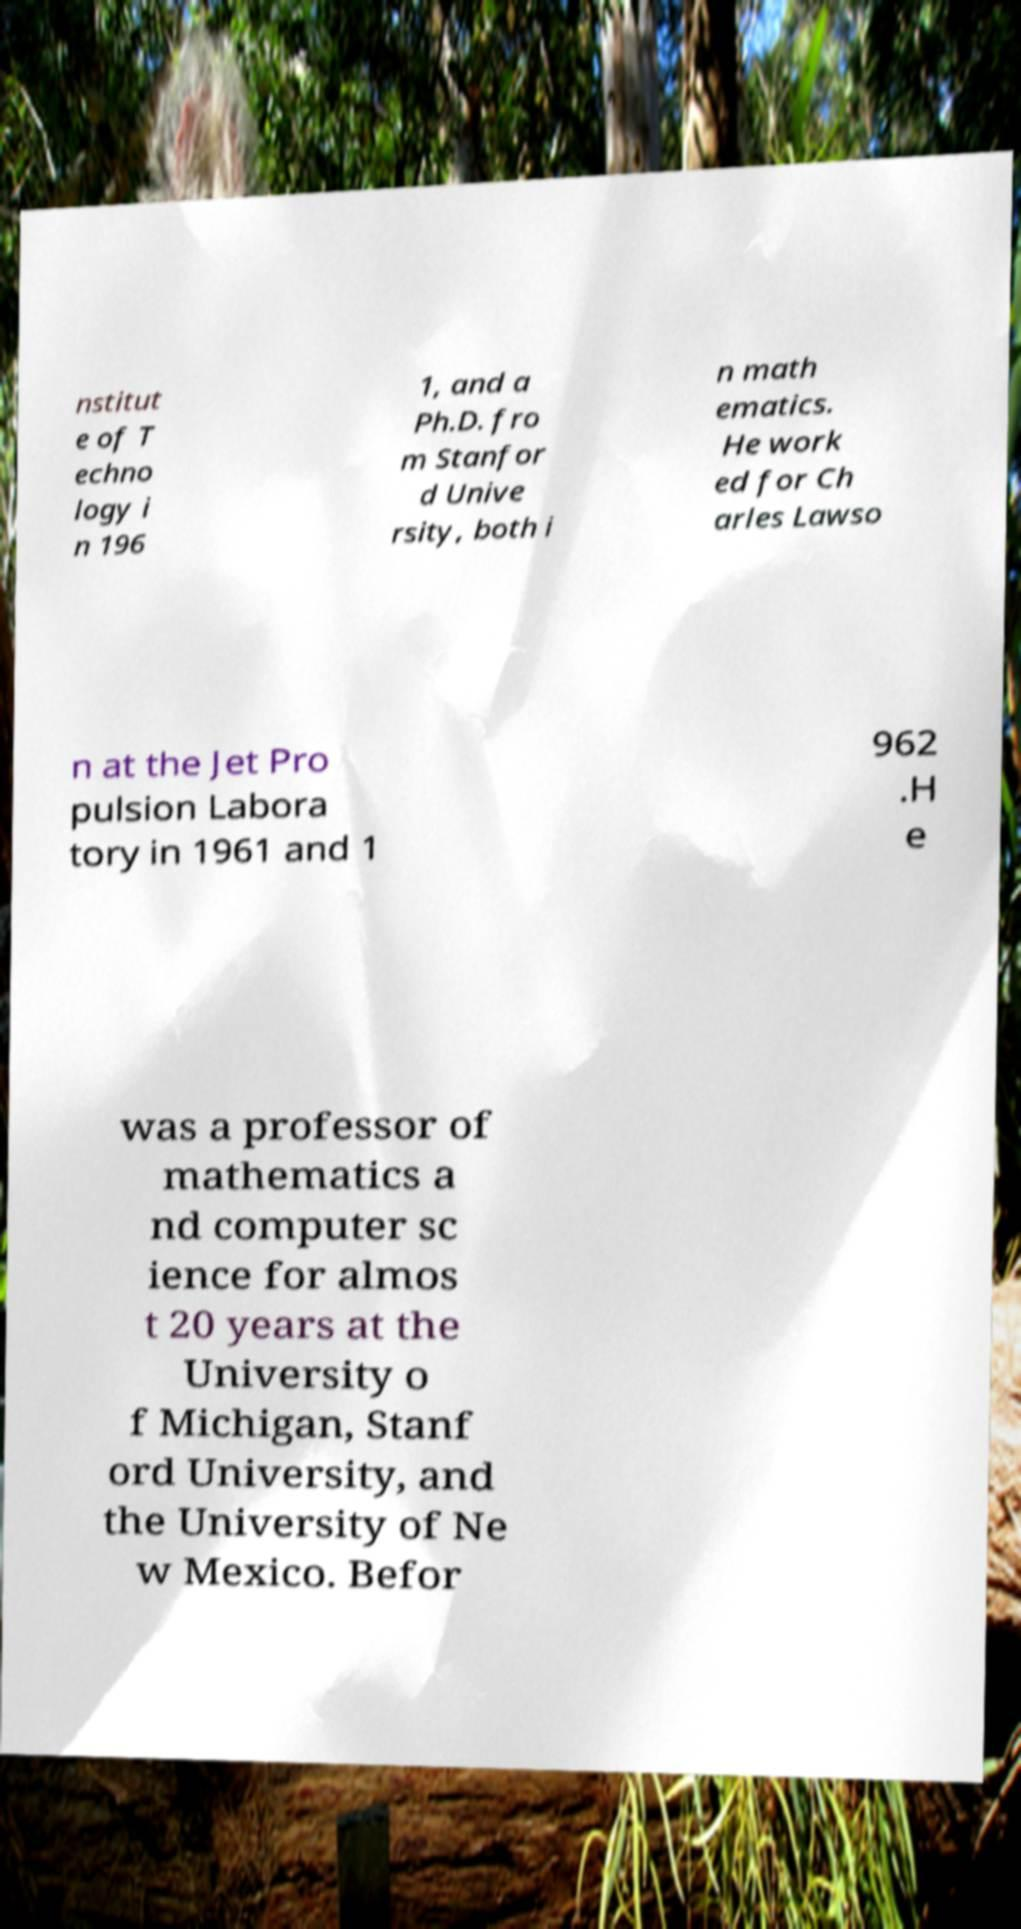Can you accurately transcribe the text from the provided image for me? nstitut e of T echno logy i n 196 1, and a Ph.D. fro m Stanfor d Unive rsity, both i n math ematics. He work ed for Ch arles Lawso n at the Jet Pro pulsion Labora tory in 1961 and 1 962 .H e was a professor of mathematics a nd computer sc ience for almos t 20 years at the University o f Michigan, Stanf ord University, and the University of Ne w Mexico. Befor 